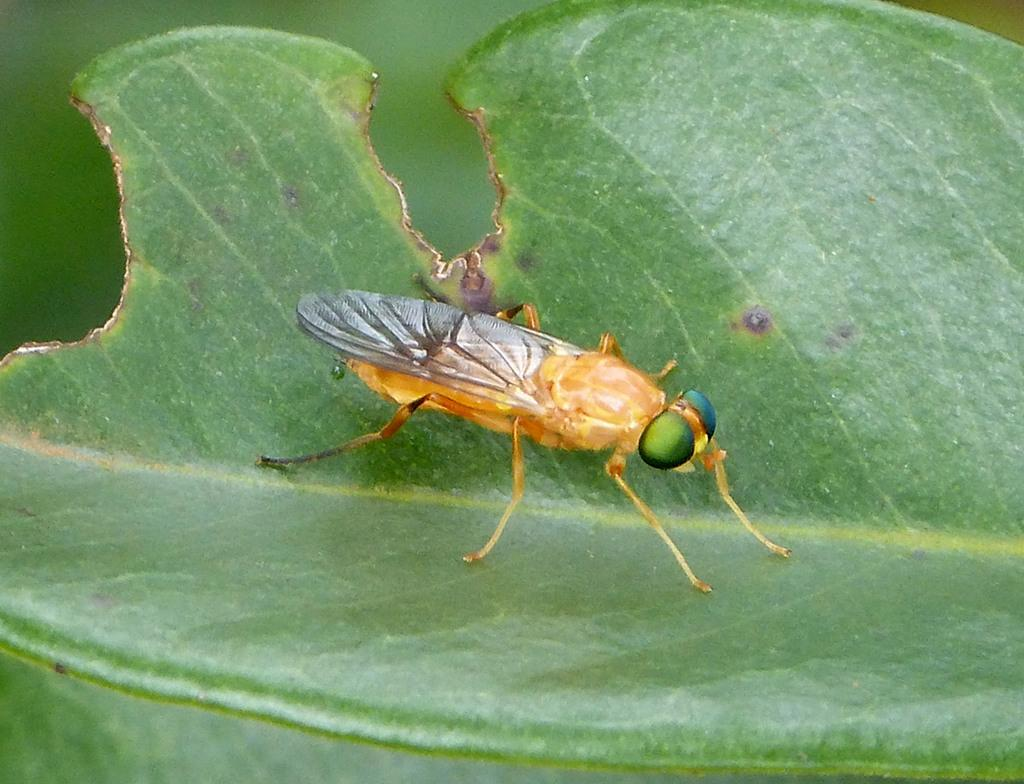What type of insect can be seen in the image? There is a brown color insect in the image. Where is the insect located? The insect is sitting on a green leaf. What can be observed about the background of the image? The background of the image is blurred. What type of liquid can be seen dripping from the ant's mouth in the image? There is no ant present in the image, and therefore no liquid dripping from its mouth. 